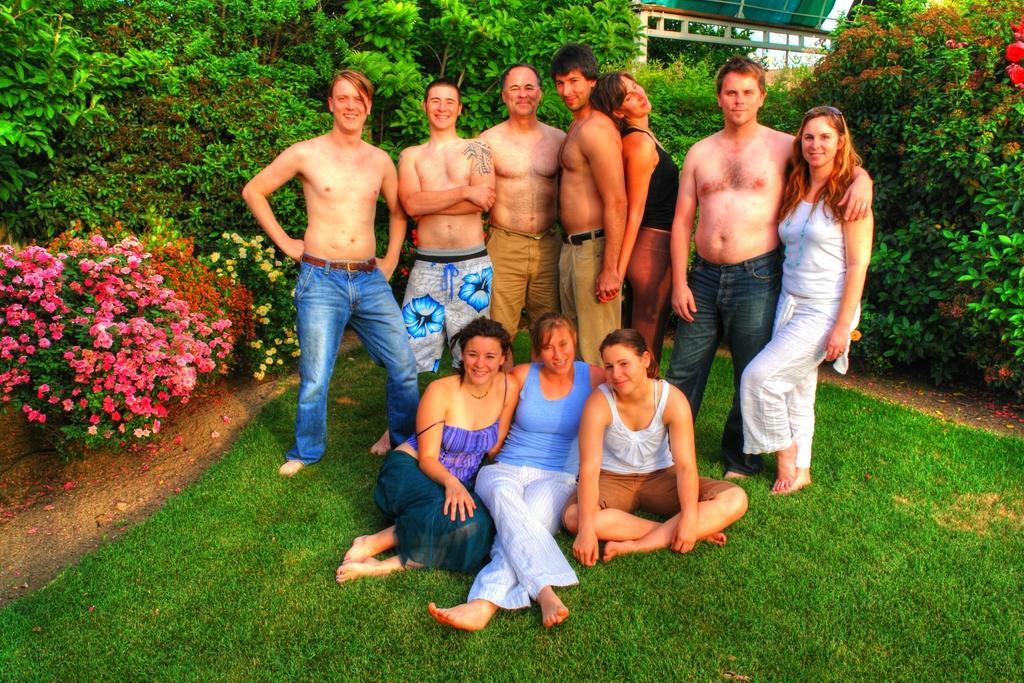How would you summarize this image in a sentence or two? This picture is taken in a garden area. Few people are standing. In front of them three women are sitting. In the background there are trees, flower plants, shelter. 